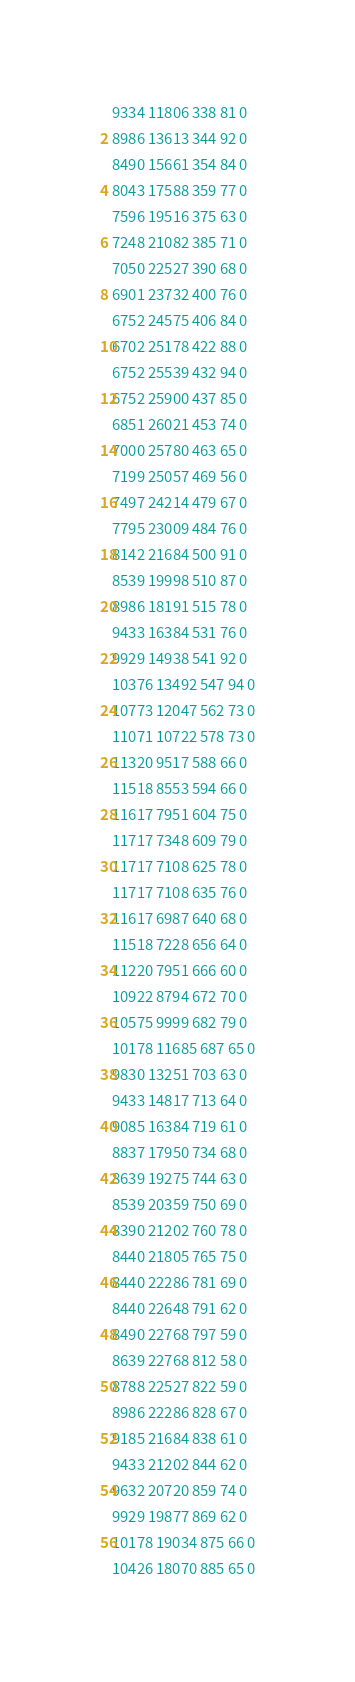Convert code to text. <code><loc_0><loc_0><loc_500><loc_500><_SML_>9334 11806 338 81 0
8986 13613 344 92 0
8490 15661 354 84 0
8043 17588 359 77 0
7596 19516 375 63 0
7248 21082 385 71 0
7050 22527 390 68 0
6901 23732 400 76 0
6752 24575 406 84 0
6702 25178 422 88 0
6752 25539 432 94 0
6752 25900 437 85 0
6851 26021 453 74 0
7000 25780 463 65 0
7199 25057 469 56 0
7497 24214 479 67 0
7795 23009 484 76 0
8142 21684 500 91 0
8539 19998 510 87 0
8986 18191 515 78 0
9433 16384 531 76 0
9929 14938 541 92 0
10376 13492 547 94 0
10773 12047 562 73 0
11071 10722 578 73 0
11320 9517 588 66 0
11518 8553 594 66 0
11617 7951 604 75 0
11717 7348 609 79 0
11717 7108 625 78 0
11717 7108 635 76 0
11617 6987 640 68 0
11518 7228 656 64 0
11220 7951 666 60 0
10922 8794 672 70 0
10575 9999 682 79 0
10178 11685 687 65 0
9830 13251 703 63 0
9433 14817 713 64 0
9085 16384 719 61 0
8837 17950 734 68 0
8639 19275 744 63 0
8539 20359 750 69 0
8390 21202 760 78 0
8440 21805 765 75 0
8440 22286 781 69 0
8440 22648 791 62 0
8490 22768 797 59 0
8639 22768 812 58 0
8788 22527 822 59 0
8986 22286 828 67 0
9185 21684 838 61 0
9433 21202 844 62 0
9632 20720 859 74 0
9929 19877 869 62 0
10178 19034 875 66 0
10426 18070 885 65 0</code> 